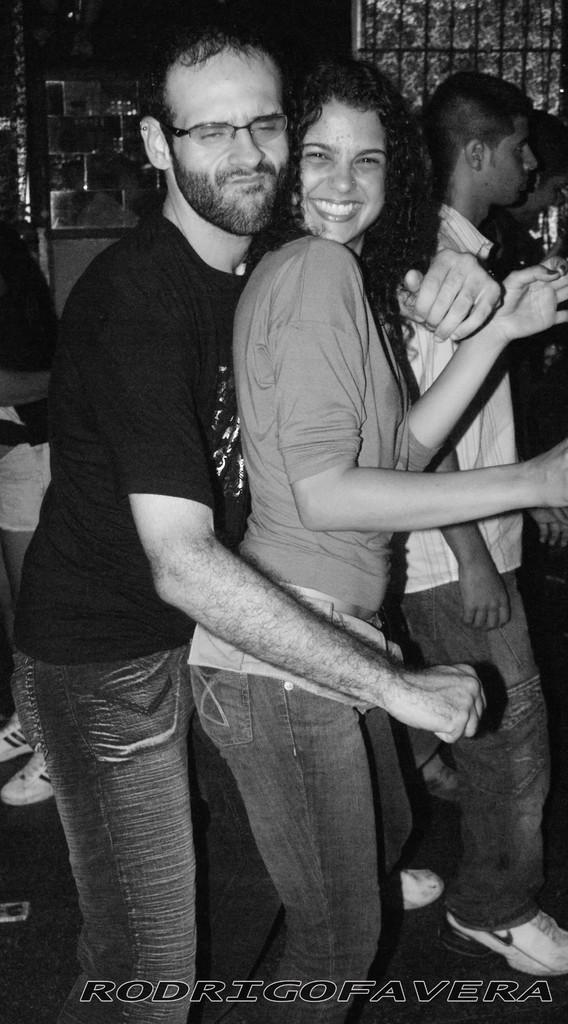Could you give a brief overview of what you see in this image? In this image there is one man and one woman standing and they are dancing, and in the background there are some people and some objects. At the bottom there is floor, and at the bottom of the image there is text. 